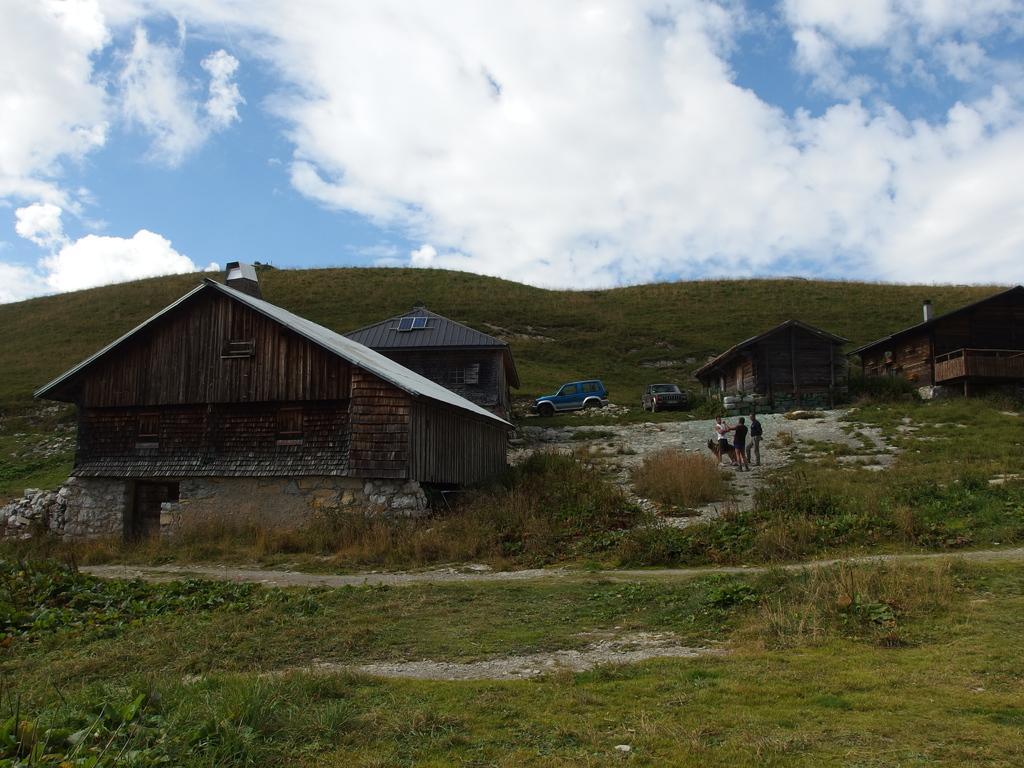Can you describe this image briefly? This picture is clicked outside the city. In the foreground we can see the green grass and the plants. In the center we can see the group of people and the houses and some vehicles parked on the ground. In the background there is a sky which is full of clouds and we can see the hills. 